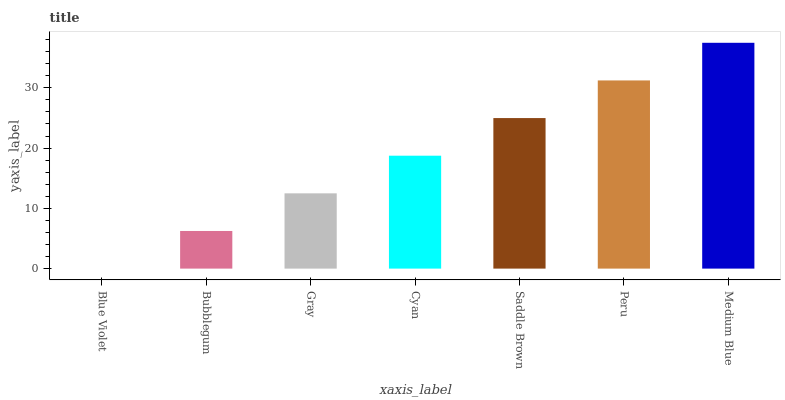Is Blue Violet the minimum?
Answer yes or no. Yes. Is Medium Blue the maximum?
Answer yes or no. Yes. Is Bubblegum the minimum?
Answer yes or no. No. Is Bubblegum the maximum?
Answer yes or no. No. Is Bubblegum greater than Blue Violet?
Answer yes or no. Yes. Is Blue Violet less than Bubblegum?
Answer yes or no. Yes. Is Blue Violet greater than Bubblegum?
Answer yes or no. No. Is Bubblegum less than Blue Violet?
Answer yes or no. No. Is Cyan the high median?
Answer yes or no. Yes. Is Cyan the low median?
Answer yes or no. Yes. Is Bubblegum the high median?
Answer yes or no. No. Is Peru the low median?
Answer yes or no. No. 